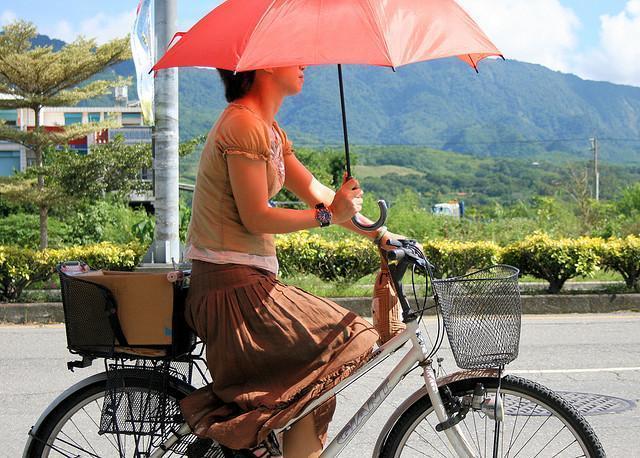Is the given caption "The bicycle is under the person." fitting for the image?
Answer yes or no. Yes. 